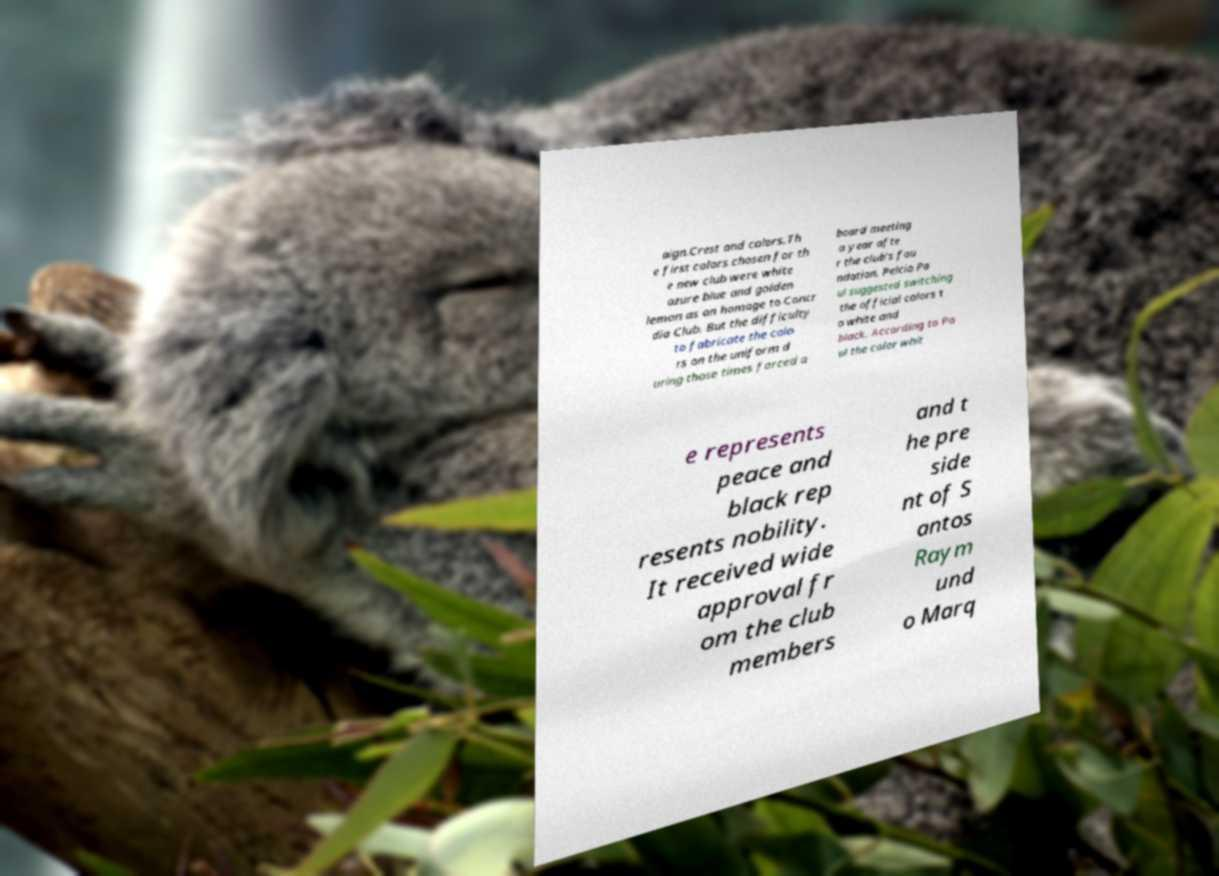Please read and relay the text visible in this image. What does it say? aign.Crest and colors.Th e first colors chosen for th e new club were white azure blue and golden lemon as an homage to Concr dia Club. But the difficulty to fabricate the colo rs on the uniform d uring those times forced a board meeting a year afte r the club's fou ndation. Pelcio Pa ul suggested switching the official colors t o white and black. According to Pa ul the color whit e represents peace and black rep resents nobility. It received wide approval fr om the club members and t he pre side nt of S antos Raym und o Marq 